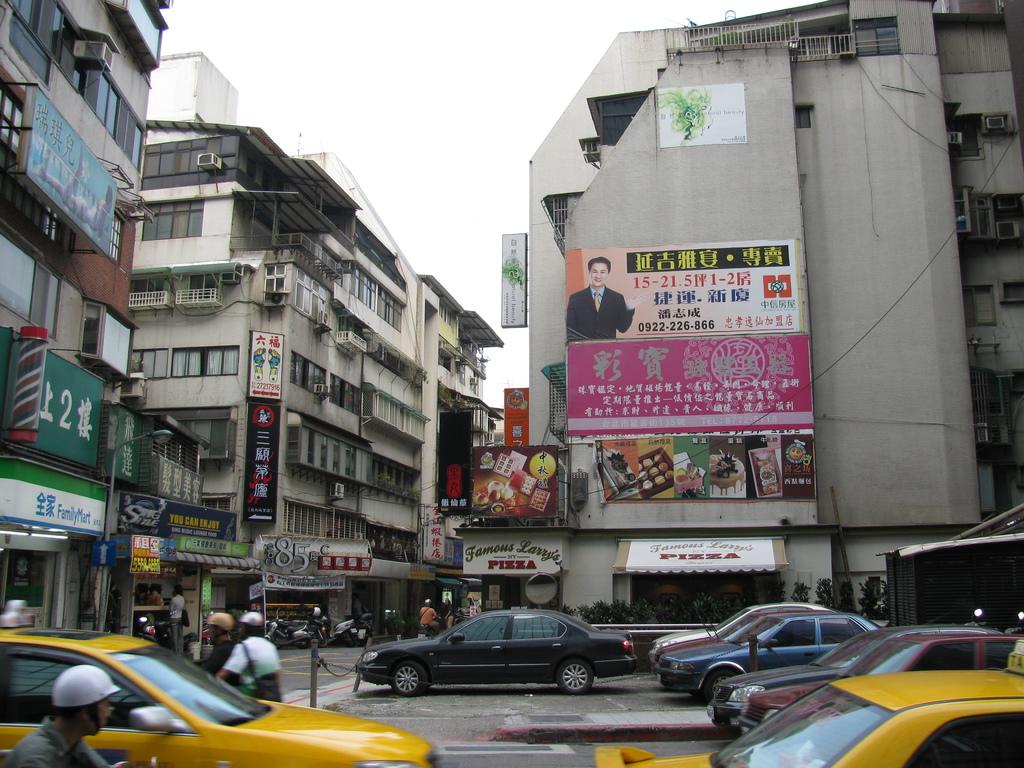What number is written on the large green sign on the left?
Make the answer very short. 2. What kind of food is served at the restaurant?
Give a very brief answer. Pizza. 